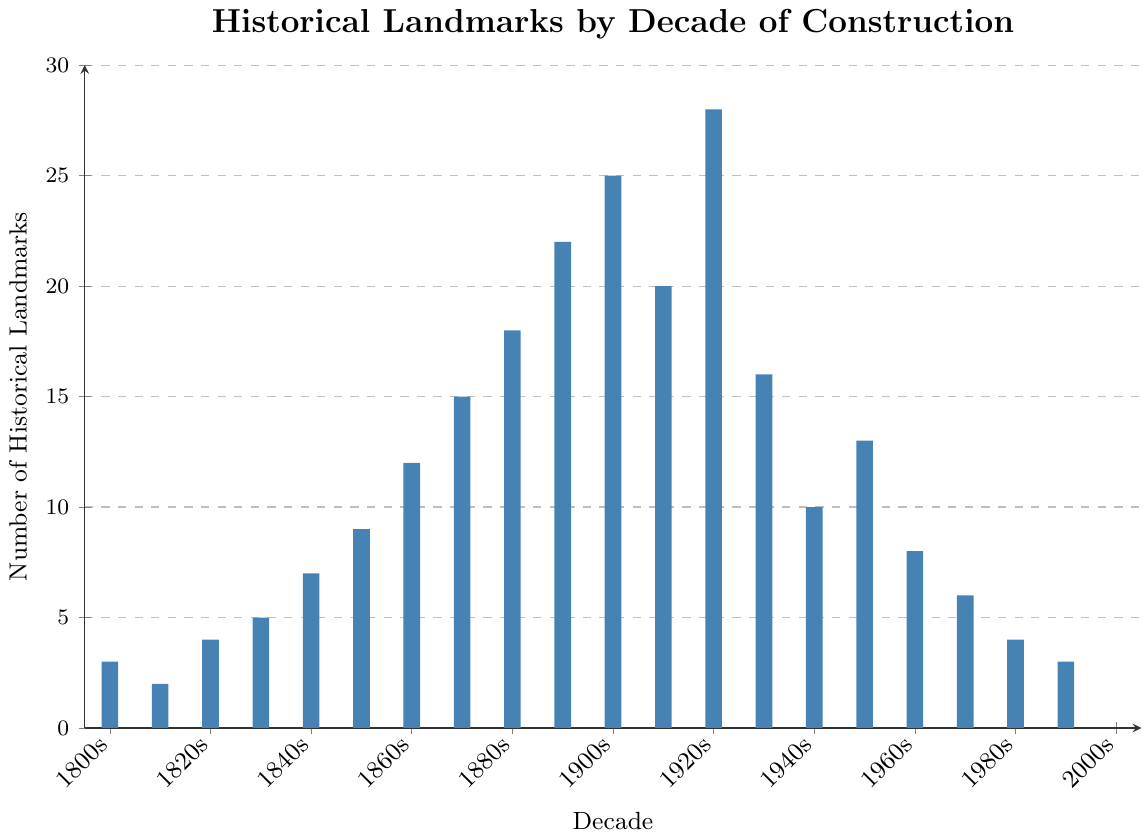Which decade has the highest number of historical landmarks? By looking at the highest bar on the chart, it is the 1920s. The height of the bar shows 28 landmarks.
Answer: 1920s How many more historical landmarks were built in the 1920s than in the 1860s? The bar for the 1920s shows 28 landmarks, and the bar for the 1860s shows 12 landmarks. The difference is 28 - 12 = 16.
Answer: 16 Comparing the 1970s and 1980s, which decade had more historical landmarks, and by how many? The bar for the 1970s shows 6 landmarks and the bar for the 1980s shows 4 landmarks. Comparing these, the 1970s had 6 - 4 = 2 more landmarks.
Answer: 1970s, 2 What is the average number of historical landmarks built per decade from the 1800s to the 1990s? Sum the landmarks in each decade and divide by the number of decades. The total is 3 + 2 + 4 + 5 + 7 + 9 + 12 + 15 + 18 + 22 + 25 + 20 + 28 + 16 + 10 + 13 + 8 + 6 + 4 + 3 = 231 landmarks across 20 decades. The average is 231 / 20 = 11.55.
Answer: 11.55 Which decade saw a decrease in the number of historical landmarks compared to the previous decade by the largest amount? By looking at the bars, from the 1920s to the 1930s, there is a decrease from 28 to 16 landmarks, which is a decrease of 12. This is the largest drop when looking at consecutive decades.
Answer: 1930s Between which consecutive decades did the number of historical landmarks increase the most? The largest increase is between the 1890s and 1900s, going from 22 to 25 landmarks, an increase of 3. No other consecutive decades have a higher increase.
Answer: 1910s - 1920s How many decades had fewer than 10 historical landmarks built? Count the bars that are lower than the 10 landmarks mark. They are 1800s, 1810s, 1820s, 1830s, 1840s, 1850s, 1960s, 1970s, 1980s, and 1990s, making a total of 10 decades.
Answer: 10 What is the total number of historical landmarks built in the 19th century (1800s to 1890s)? Sum the number of landmarks from each decade from the 1800s to the 1890s. The total is 3 + 2 + 4 + 5 + 7 + 9 + 12 + 15 + 18 + 22 = 97.
Answer: 97 What is the median number of historical landmarks built per decade from the 1800s to the 1990s? Arrange the number of landmarks for each decade in ascending order: 2, 3, 3, 4, 4, 5, 6, 7, 8, 9, 10, 12, 13, 15, 16, 18, 20, 22, 25, 28. Since there are 20 data points, the median will be the average of the 10th and 11th values: (9 + 10) / 2 = 9.5.
Answer: 9.5 